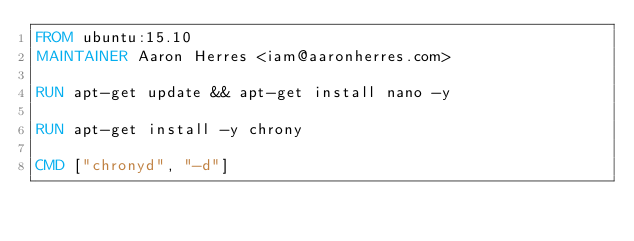Convert code to text. <code><loc_0><loc_0><loc_500><loc_500><_Dockerfile_>FROM ubuntu:15.10
MAINTAINER Aaron Herres <iam@aaronherres.com>

RUN apt-get update && apt-get install nano -y

RUN apt-get install -y chrony

CMD ["chronyd", "-d"]
</code> 